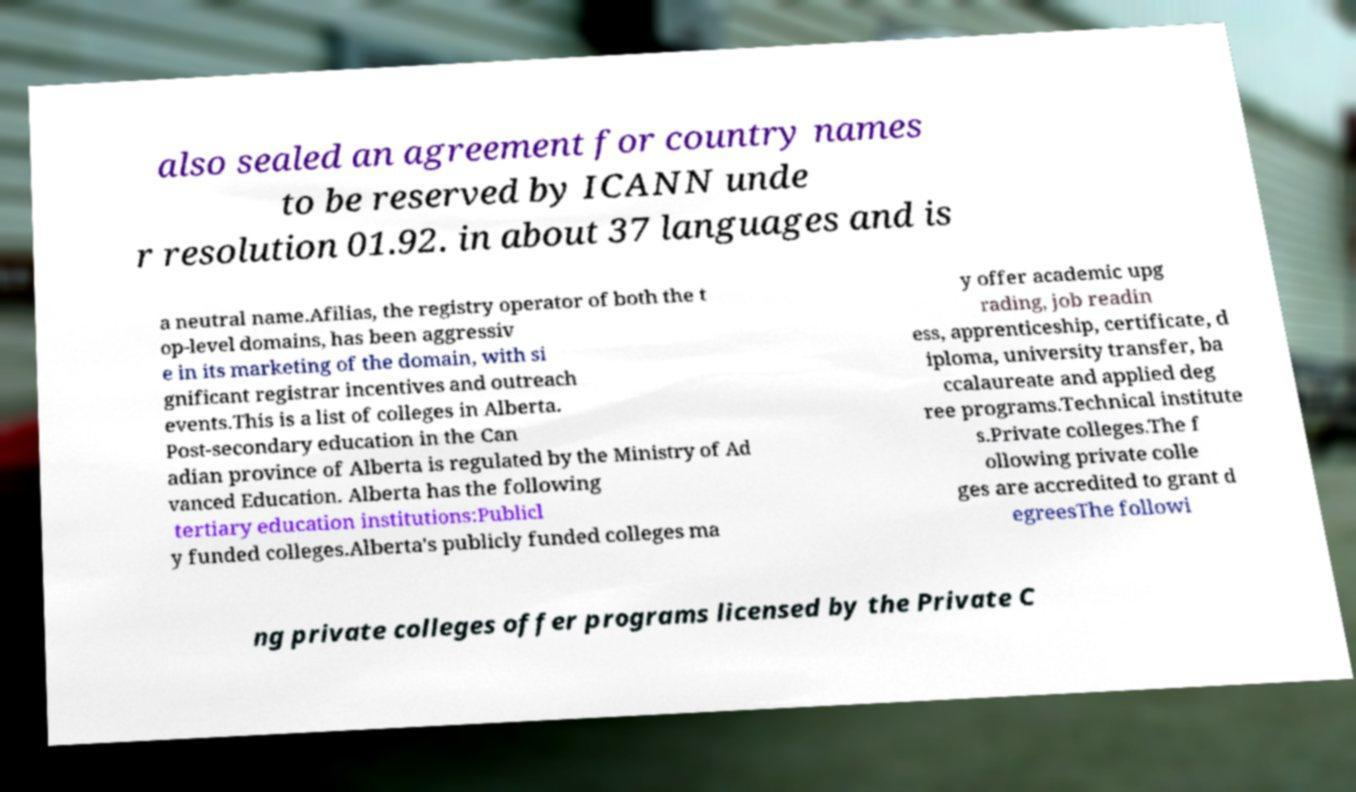Can you read and provide the text displayed in the image?This photo seems to have some interesting text. Can you extract and type it out for me? also sealed an agreement for country names to be reserved by ICANN unde r resolution 01.92. in about 37 languages and is a neutral name.Afilias, the registry operator of both the t op-level domains, has been aggressiv e in its marketing of the domain, with si gnificant registrar incentives and outreach events.This is a list of colleges in Alberta. Post-secondary education in the Can adian province of Alberta is regulated by the Ministry of Ad vanced Education. Alberta has the following tertiary education institutions:Publicl y funded colleges.Alberta's publicly funded colleges ma y offer academic upg rading, job readin ess, apprenticeship, certificate, d iploma, university transfer, ba ccalaureate and applied deg ree programs.Technical institute s.Private colleges.The f ollowing private colle ges are accredited to grant d egreesThe followi ng private colleges offer programs licensed by the Private C 